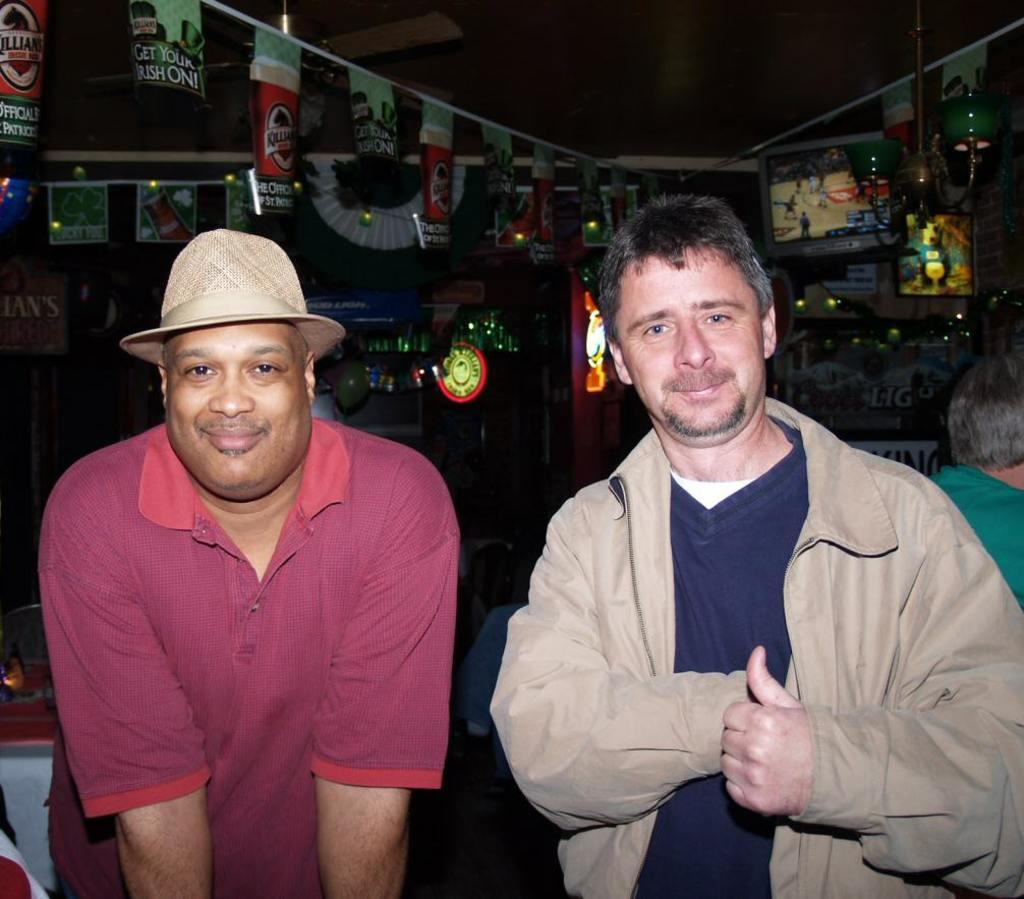How many people are present in the image? There are two people standing in the image. What object can be seen providing air circulation in the image? There is a fan visible in the image. What decorative items are tied to a rope in the image? There are flags tied to a rope in the image. Where is the faucet located in the image? There is no faucet present in the image. What type of punishment is being administered to the people in the image? There is no indication of punishment in the image; the two people are simply standing. 